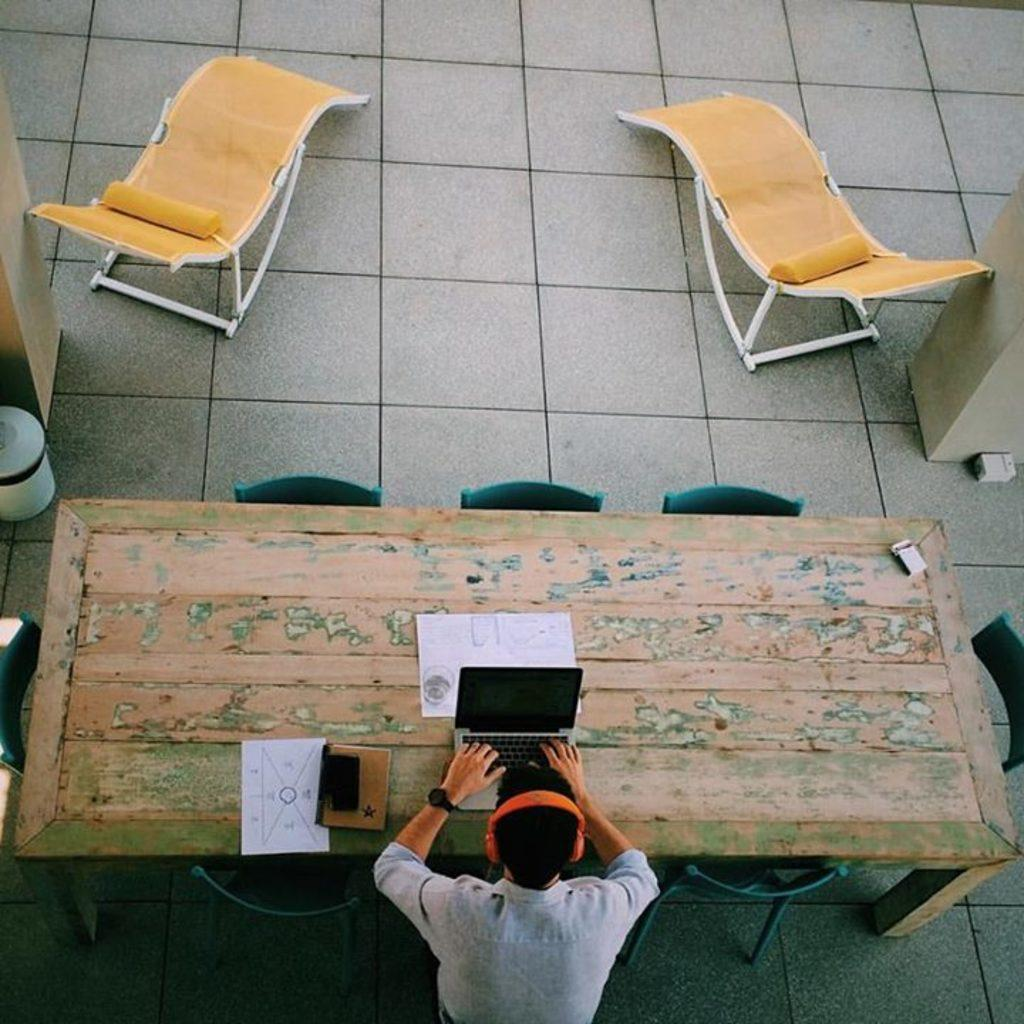What is the main setting of the image? There is a room in the image. What is the person in the room doing? The person is sitting on a chair in the room. What accessories is the person wearing? The person is wearing headphones and a watch. What furniture is present in the room? There is a table in the room. What electronic device is on the table? There is a laptop on the table. What else is on the table? There is a paper on the table. What can be seen in the background of the room? In the background, there is a pillar and a chair. What type of wealth is displayed on the list in the image? There is no list present in the image, so it is not possible to determine what type of wealth might be displayed. 